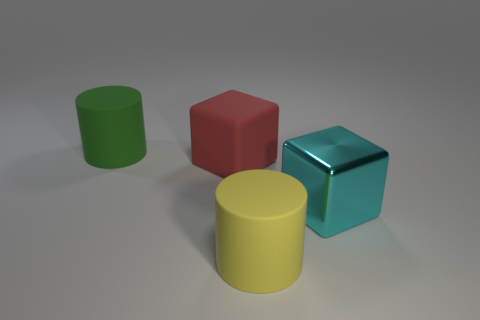Add 1 small purple matte things. How many objects exist? 5 Subtract 0 purple balls. How many objects are left? 4 Subtract all small blue metallic cylinders. Subtract all rubber things. How many objects are left? 1 Add 1 cyan cubes. How many cyan cubes are left? 2 Add 1 large gray shiny spheres. How many large gray shiny spheres exist? 1 